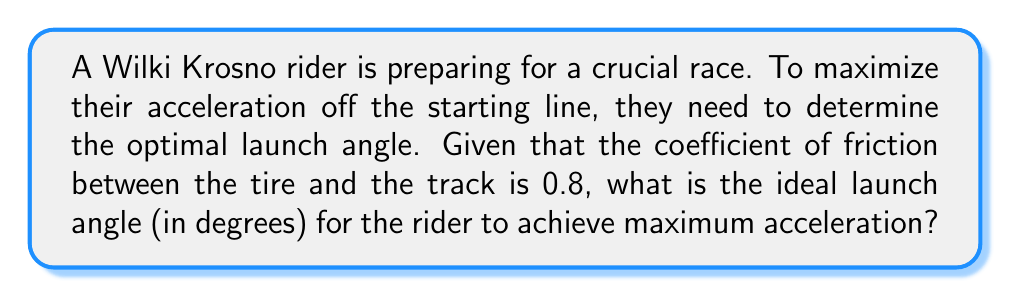Show me your answer to this math problem. Let's approach this step-by-step:

1) The optimal launch angle for maximum acceleration depends on the coefficient of friction between the tire and the track.

2) The formula for the optimal launch angle ($\theta$) is:

   $$\theta = \arctan(\frac{1}{\mu})$$

   Where $\mu$ is the coefficient of friction.

3) We're given that the coefficient of friction is 0.8.

4) Let's substitute this into our formula:

   $$\theta = \arctan(\frac{1}{0.8})$$

5) Now we can calculate:

   $$\theta = \arctan(1.25)$$

6) Using a calculator or trigonometric tables:

   $$\theta \approx 51.34^\circ$$

7) Rounding to the nearest degree:

   $$\theta \approx 51^\circ$$

This angle will provide the optimal balance between forward acceleration and maintaining traction on the track for the Wilki Krosno rider.
Answer: $51^\circ$ 